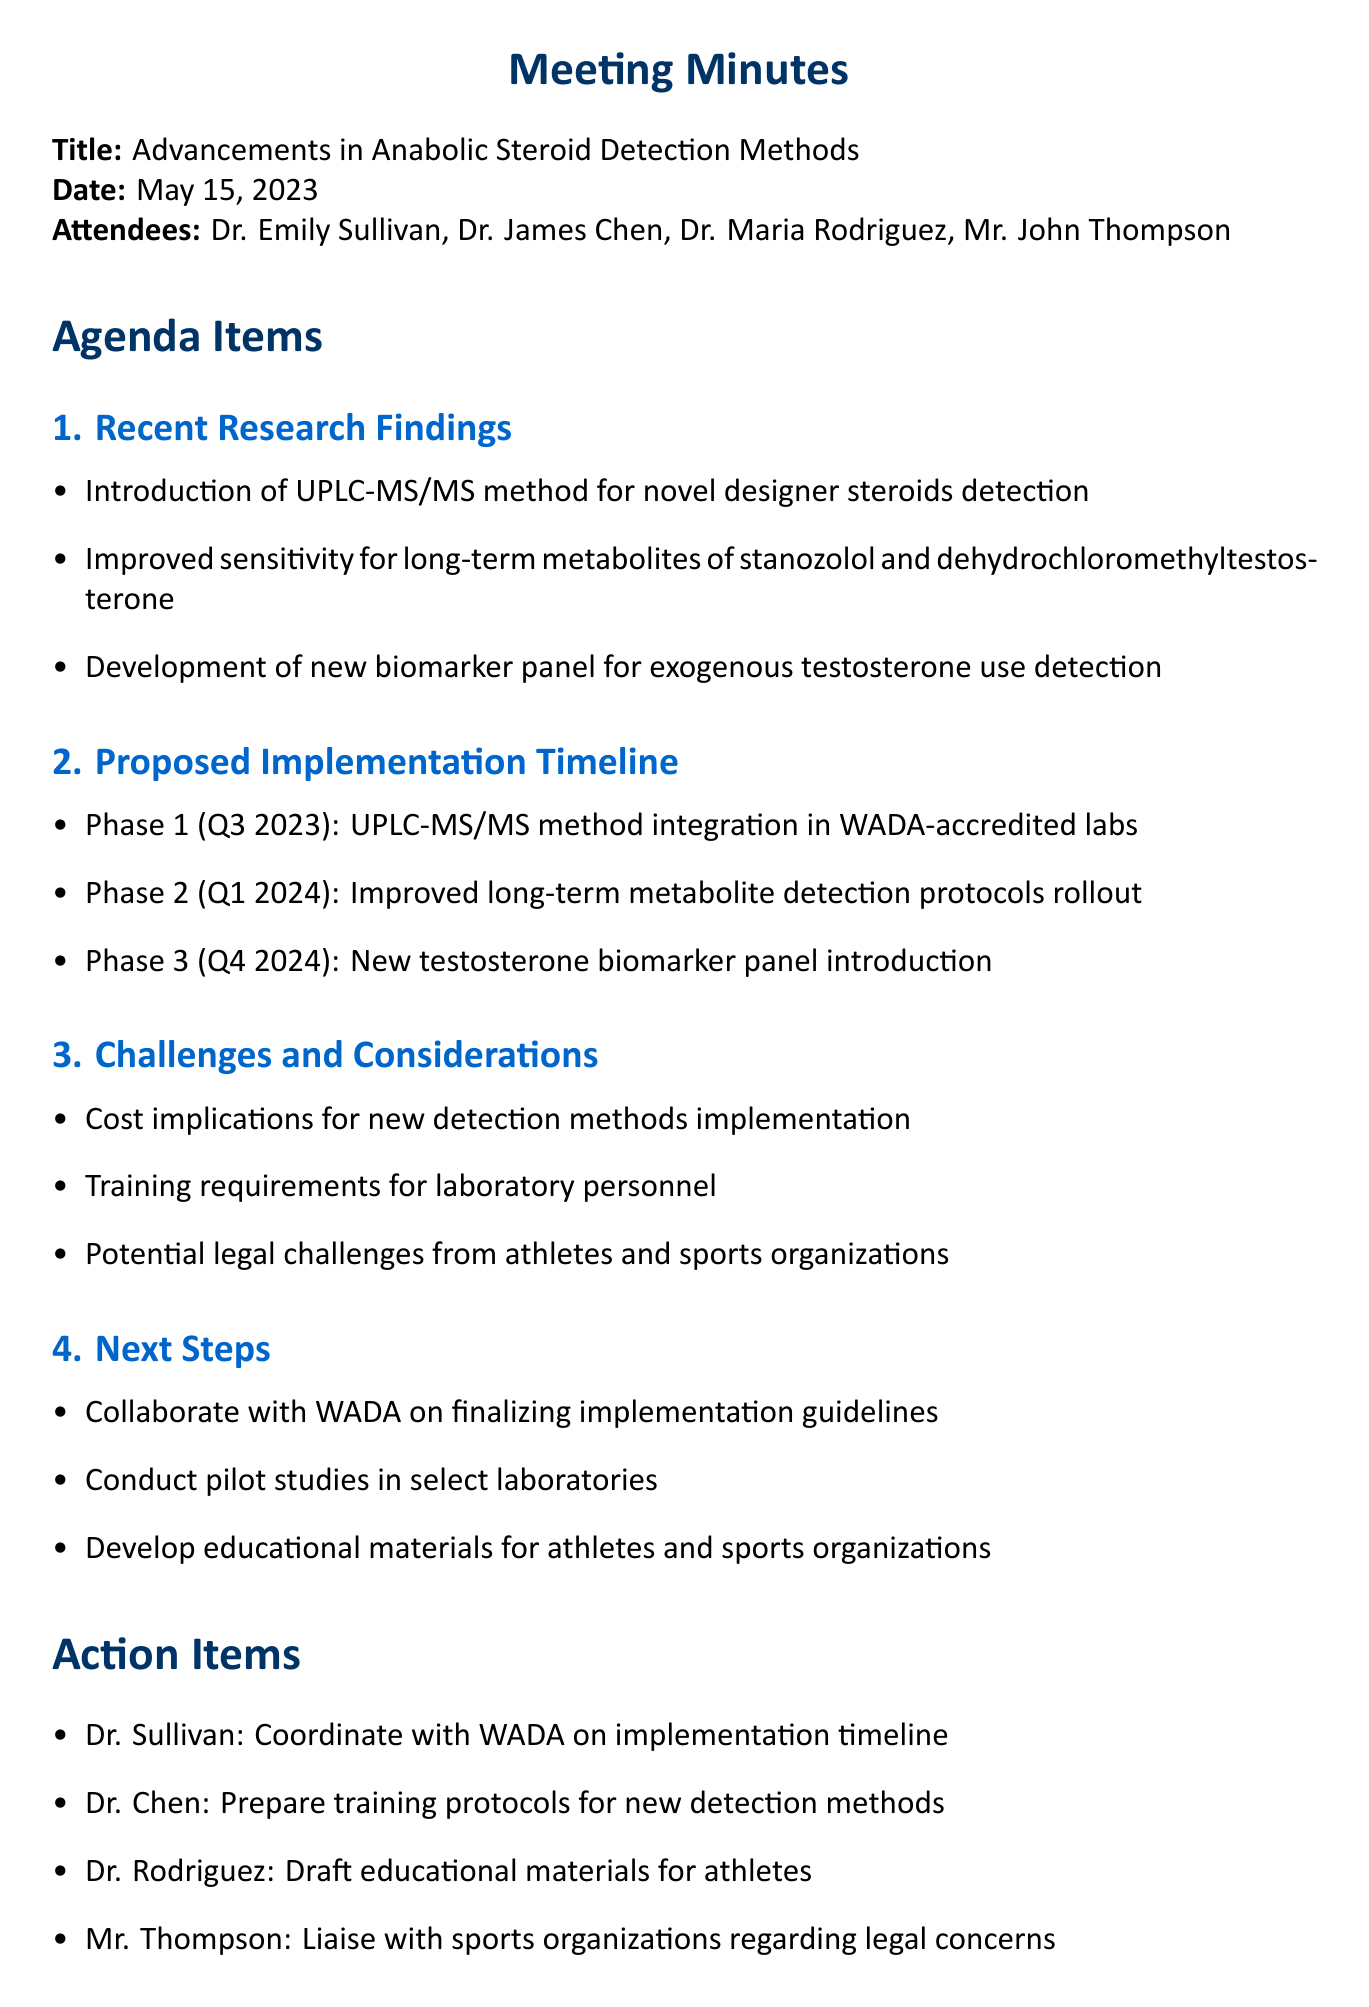What is the title of the meeting? The title of the meeting is stated at the beginning of the document.
Answer: Advancements in Anabolic Steroid Detection Methods Who presented the recent research findings? The lead investigator who is responsible for the research findings is mentioned in the attendees list.
Answer: Dr. Emily Sullivan What is the proposed Phase 1 timeline for the integration of new detection methods? The document outlines the timeline for each phase under the Proposed Implementation Timeline section.
Answer: Q3 2023 What new detection method is introduced? The recent research findings specify a new method used for detecting anabolic steroids.
Answer: UPLC-MS/MS What are the potential legal challenges mentioned? The challenges and considerations section highlights specific concerns that may arise in relation to the new detection methods.
Answer: Legal challenges from athletes and sports organizations Which attendee is responsible for preparing training protocols? The action items section includes responsibilities assigned to each attendee after the meeting.
Answer: Dr. Chen How many phases are proposed for the implementation of the new detection methods? The proposed implementation timeline indicates the phases of implementation planned.
Answer: Three What is one of the next steps mentioned for the collaboration with WADA? The next steps section includes actions to be taken after the meeting regarding the collaboration.
Answer: Finalizing implementation guidelines What is the focus of the newly developed biomarker panel? The recent research findings describe the application of a new biomarker panel in the context of steroid detection.
Answer: Exogenous testosterone use What is the cost implication mentioned in the challenges? The challenges and considerations section discusses the financial aspects of implementing new detection methods.
Answer: Cost implications for implementing new detection methods 